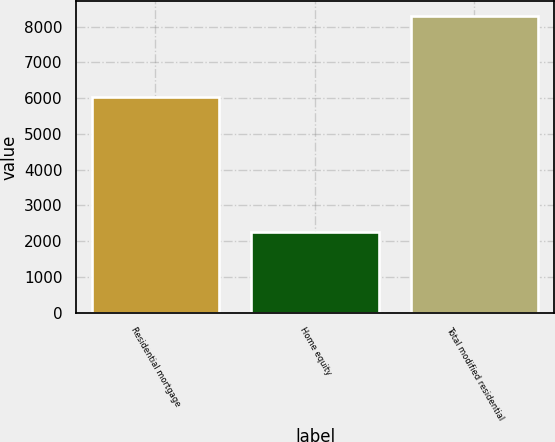Convert chart to OTSL. <chart><loc_0><loc_0><loc_500><loc_500><bar_chart><fcel>Residential mortgage<fcel>Home equity<fcel>Total modified residential<nl><fcel>6032<fcel>2264<fcel>8296<nl></chart> 